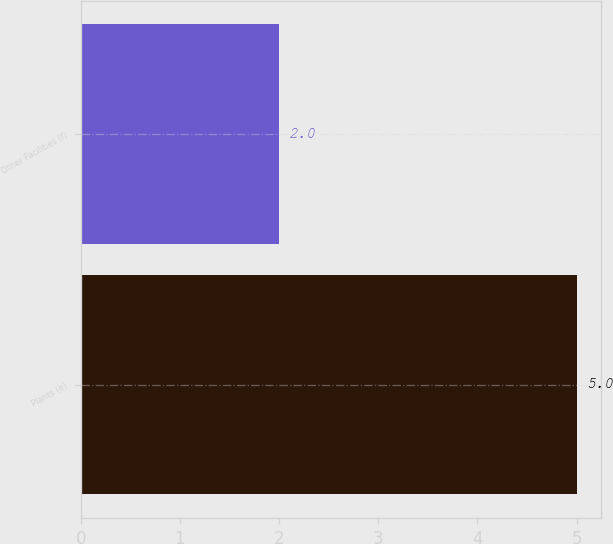Convert chart. <chart><loc_0><loc_0><loc_500><loc_500><bar_chart><fcel>Plants (e)<fcel>Other Facilities (f)<nl><fcel>5<fcel>2<nl></chart> 